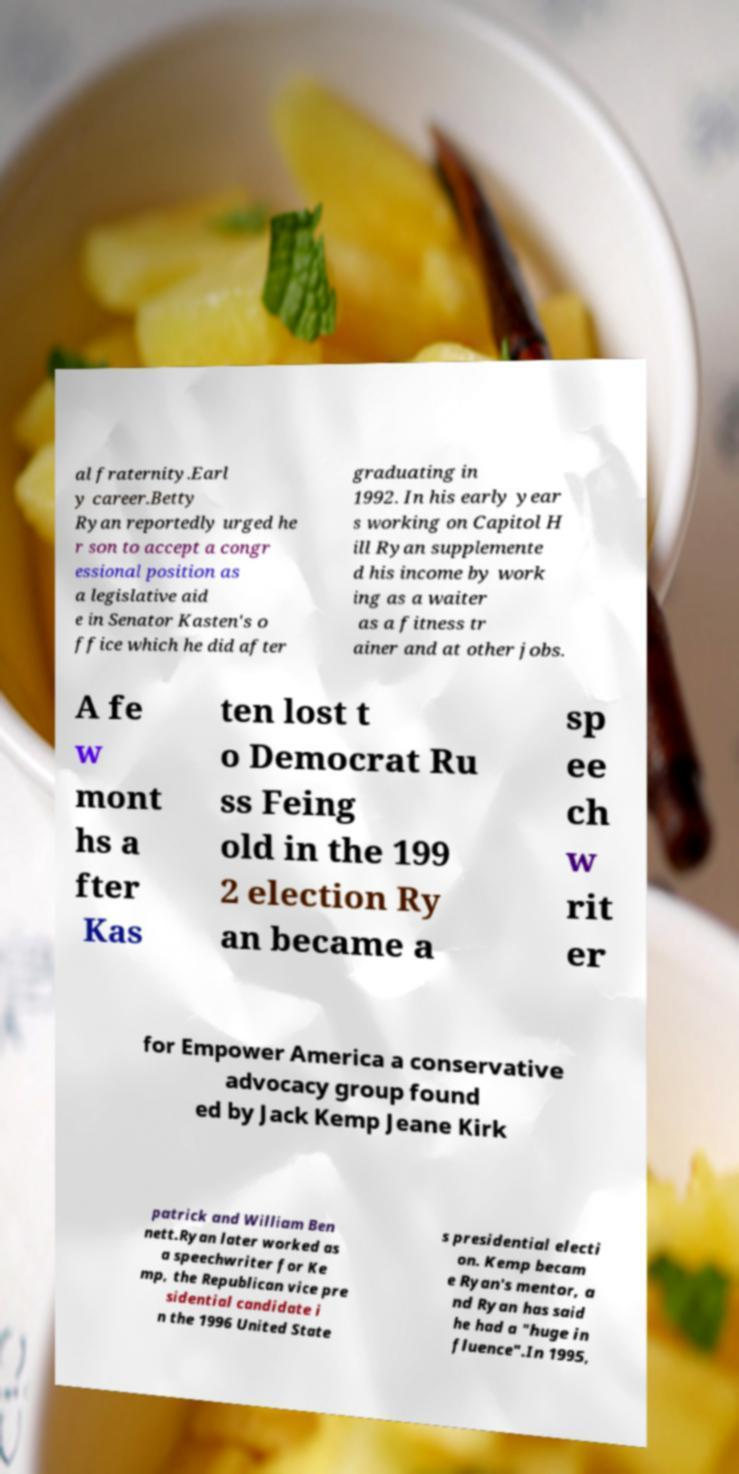Could you assist in decoding the text presented in this image and type it out clearly? al fraternity.Earl y career.Betty Ryan reportedly urged he r son to accept a congr essional position as a legislative aid e in Senator Kasten's o ffice which he did after graduating in 1992. In his early year s working on Capitol H ill Ryan supplemente d his income by work ing as a waiter as a fitness tr ainer and at other jobs. A fe w mont hs a fter Kas ten lost t o Democrat Ru ss Feing old in the 199 2 election Ry an became a sp ee ch w rit er for Empower America a conservative advocacy group found ed by Jack Kemp Jeane Kirk patrick and William Ben nett.Ryan later worked as a speechwriter for Ke mp, the Republican vice pre sidential candidate i n the 1996 United State s presidential electi on. Kemp becam e Ryan's mentor, a nd Ryan has said he had a "huge in fluence".In 1995, 